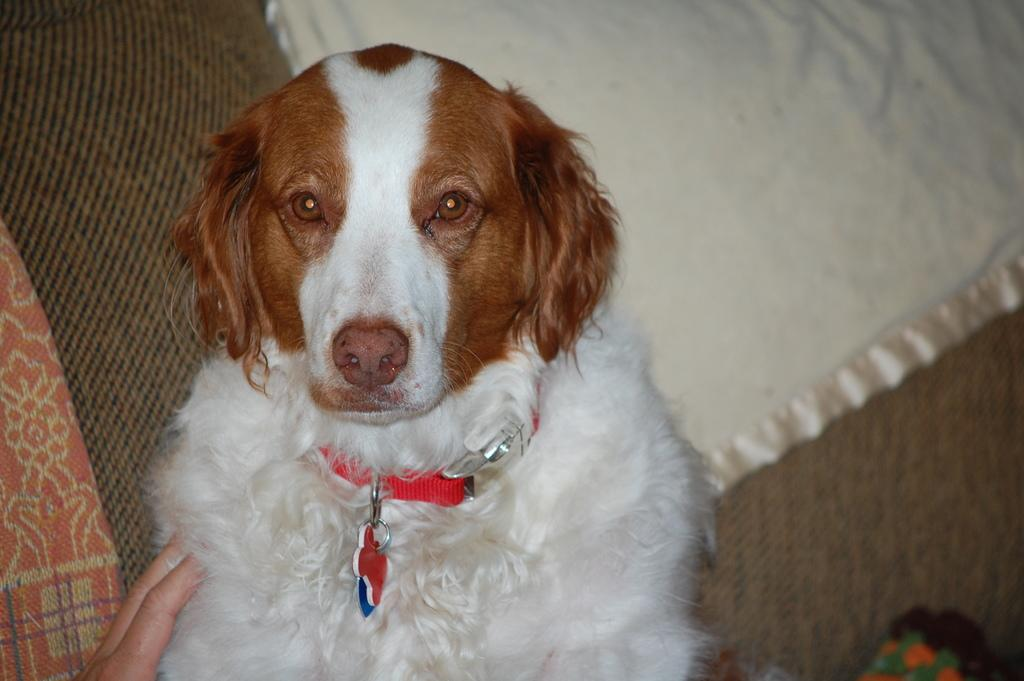What is the person holding in the image? There is a person's hand holding a dog in the image. What can be seen in the background of the image? There is a couch in the background of the image. What is on the couch? Clothes are present on the couch, and there is also an object on the couch. Is there a volcano erupting in the image? No, there is no volcano or any indication of an eruption in the image. 